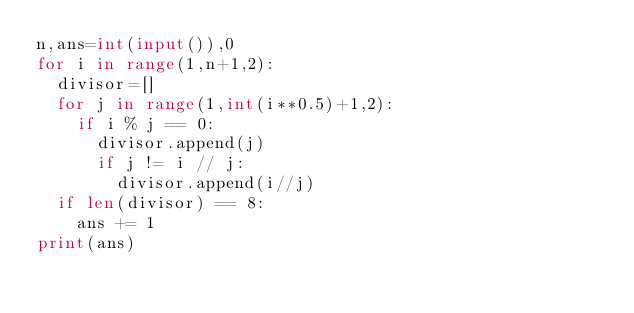<code> <loc_0><loc_0><loc_500><loc_500><_Python_>n,ans=int(input()),0
for i in range(1,n+1,2):
  divisor=[]
  for j in range(1,int(i**0.5)+1,2):
    if i % j == 0:
      divisor.append(j)
      if j != i // j:
        divisor.append(i//j)
  if len(divisor) == 8:
    ans += 1
print(ans)</code> 